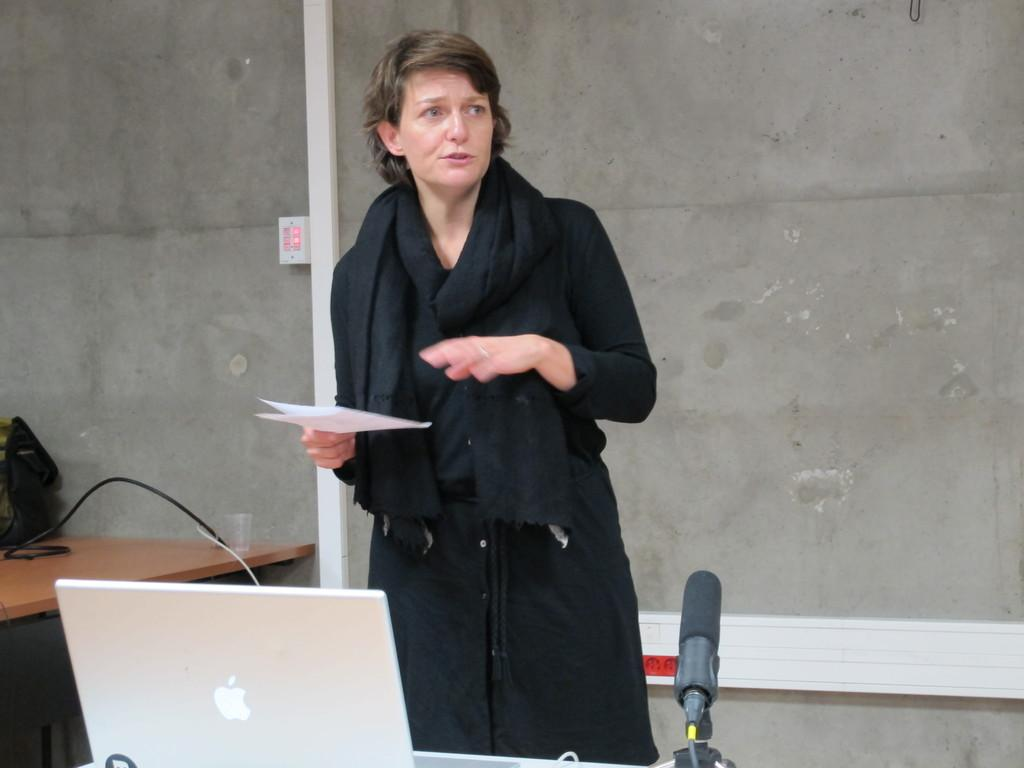What is the woman in the image holding? The woman is holding a paper. Can you describe the background of the image? There is a glass, a bag, a laptop, and a microphone on a table in the background of the image. What is the woman doing in the image? The woman is standing in the image. What object is on the table in the background of the image? There is a laptop on the table in the background of the image. How does the crowd react to the cream in the image? There is no crowd or cream present in the image. 